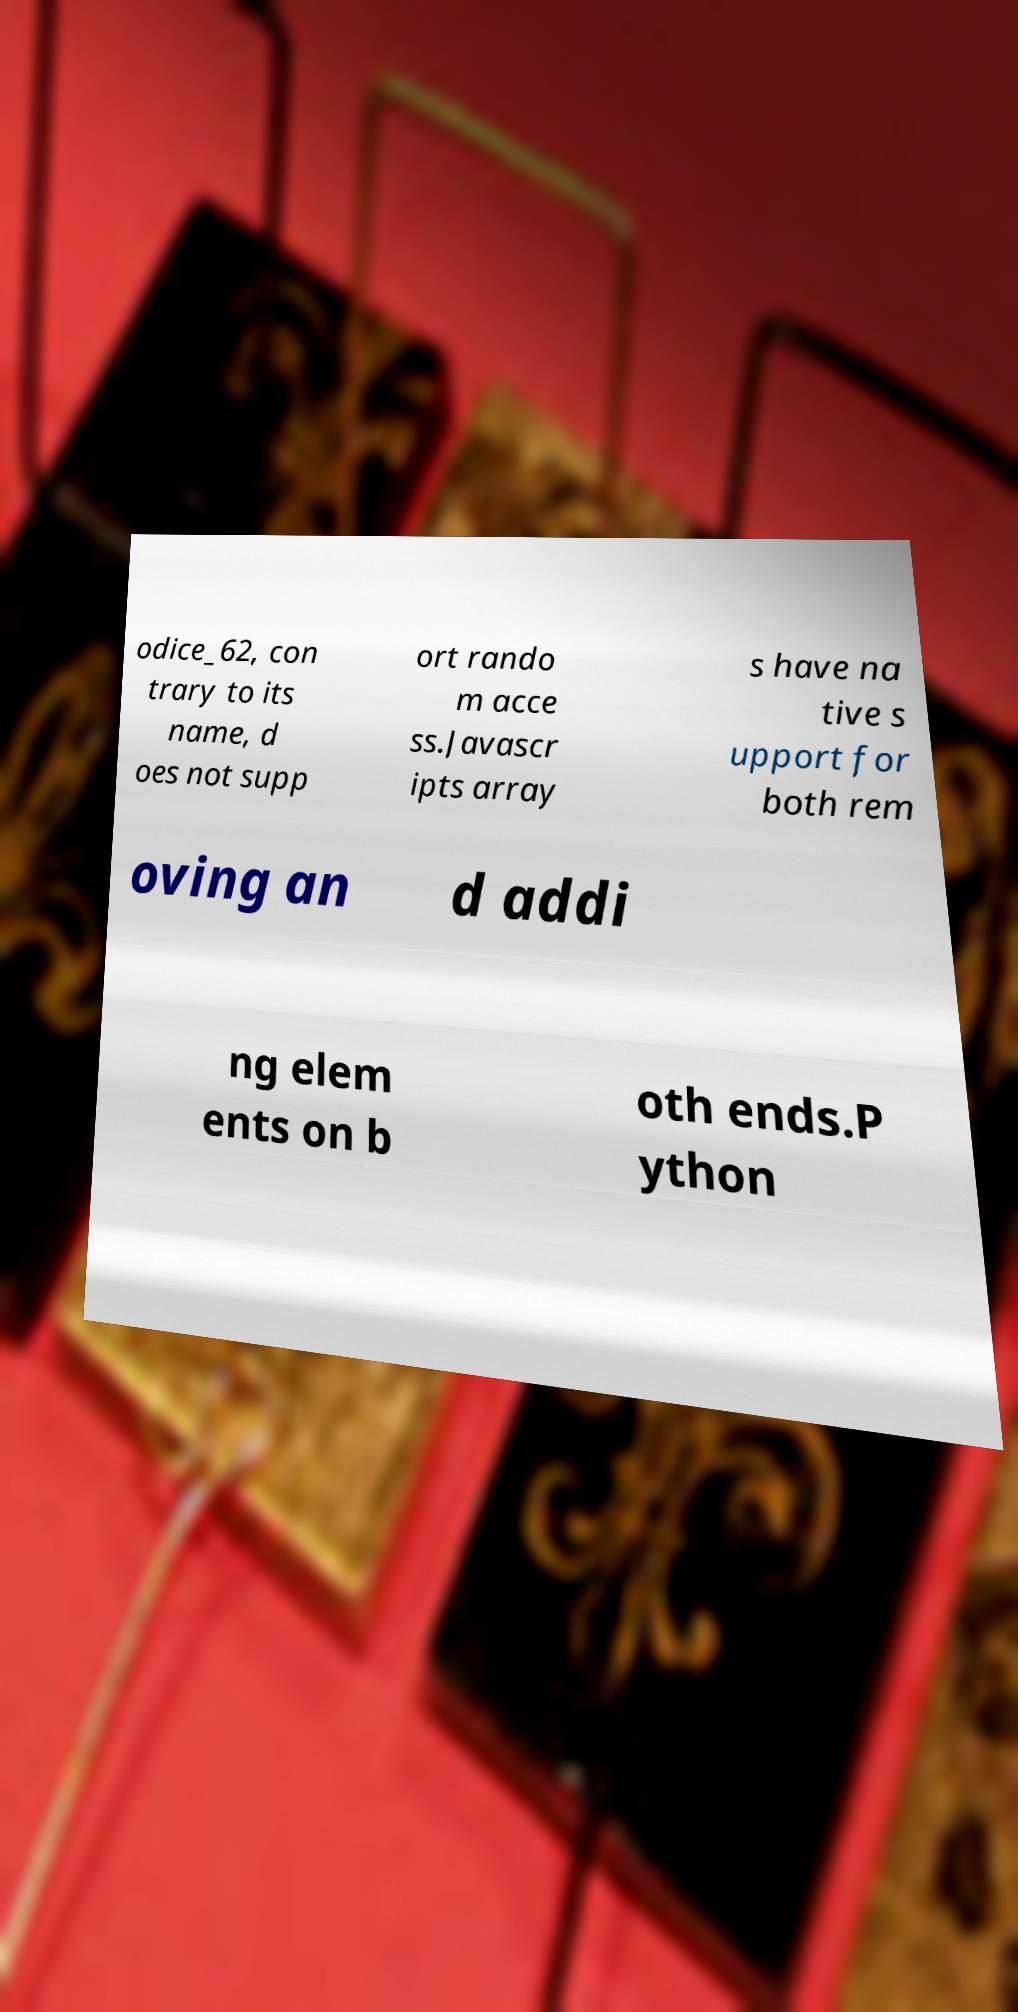Please read and relay the text visible in this image. What does it say? odice_62, con trary to its name, d oes not supp ort rando m acce ss.Javascr ipts array s have na tive s upport for both rem oving an d addi ng elem ents on b oth ends.P ython 